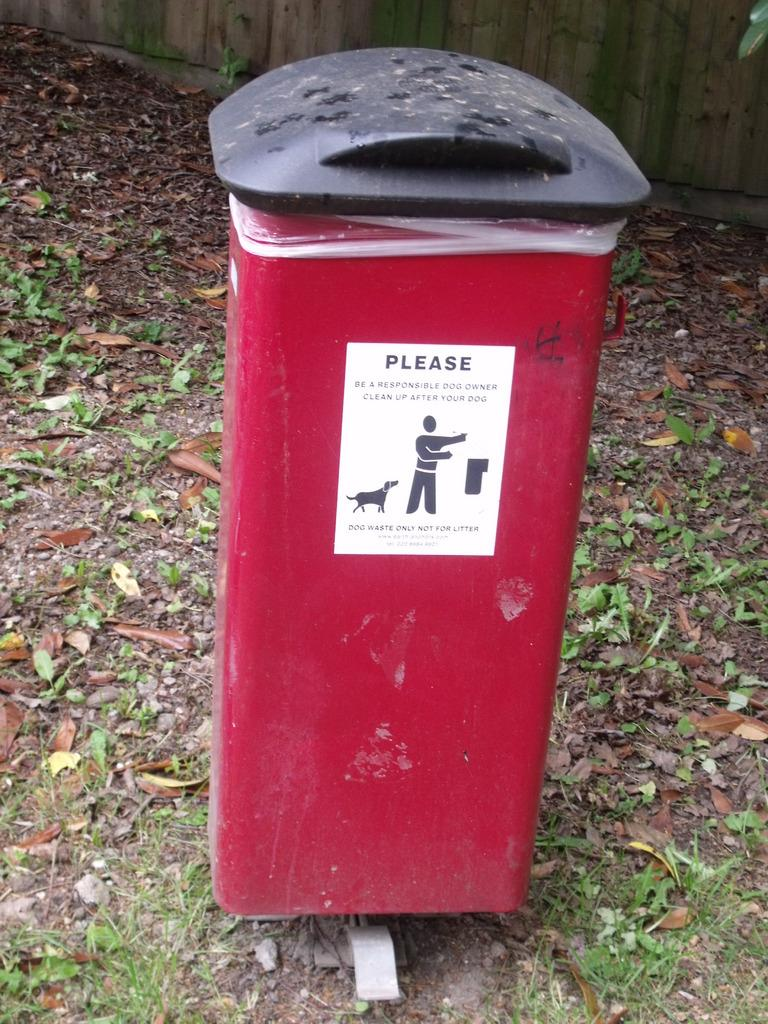<image>
Create a compact narrative representing the image presented. Trash Can that says Please Be a responsible dog owner clean up after your dog. 